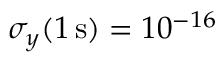Convert formula to latex. <formula><loc_0><loc_0><loc_500><loc_500>\sigma _ { y } ( 1 \, s ) = 1 0 ^ { - 1 6 }</formula> 